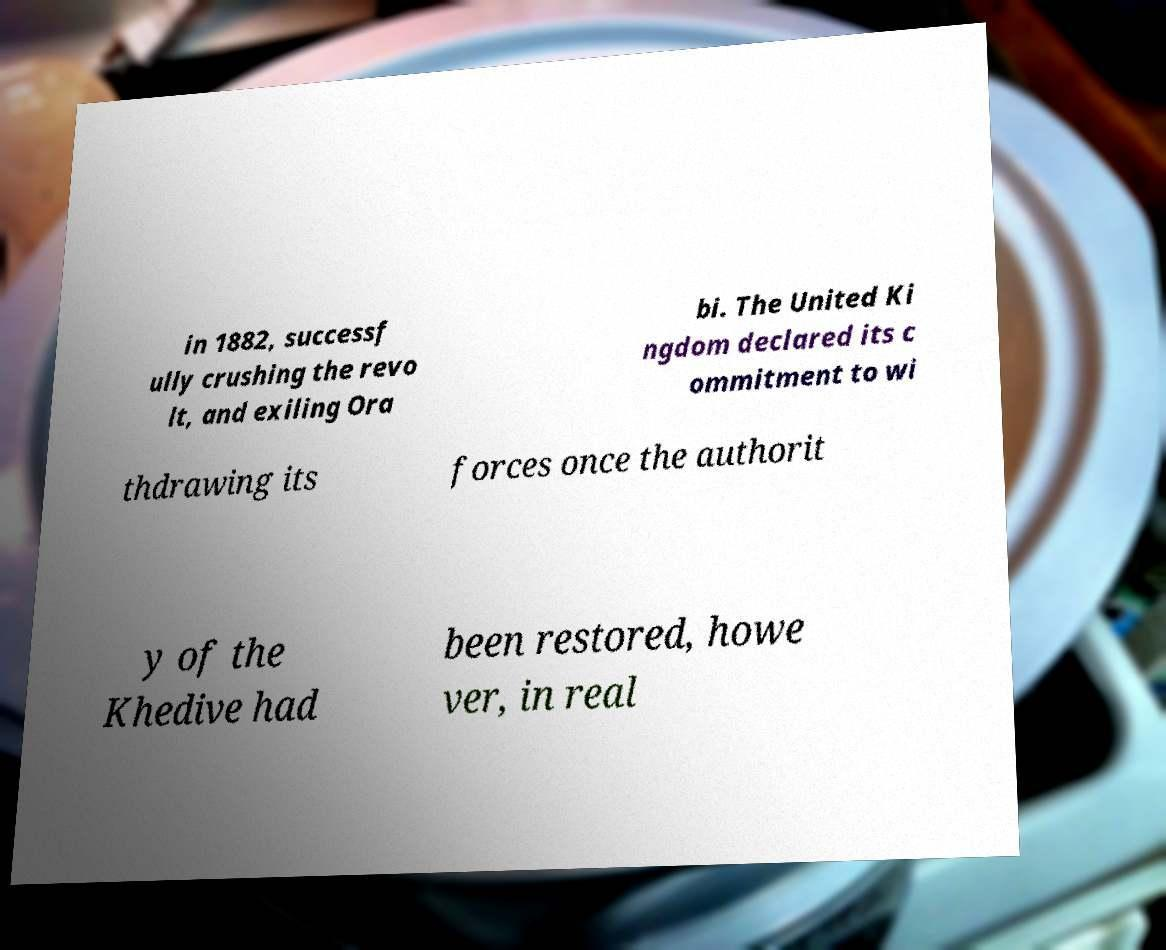Please identify and transcribe the text found in this image. in 1882, successf ully crushing the revo lt, and exiling Ora bi. The United Ki ngdom declared its c ommitment to wi thdrawing its forces once the authorit y of the Khedive had been restored, howe ver, in real 